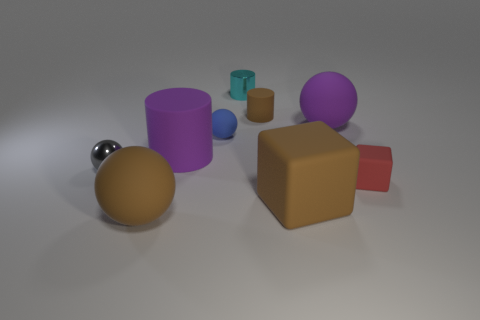Add 1 cyan shiny things. How many objects exist? 10 Subtract all cylinders. How many objects are left? 6 Subtract 1 brown cubes. How many objects are left? 8 Subtract all brown cubes. Subtract all big purple objects. How many objects are left? 6 Add 8 small metal balls. How many small metal balls are left? 9 Add 2 tiny gray spheres. How many tiny gray spheres exist? 3 